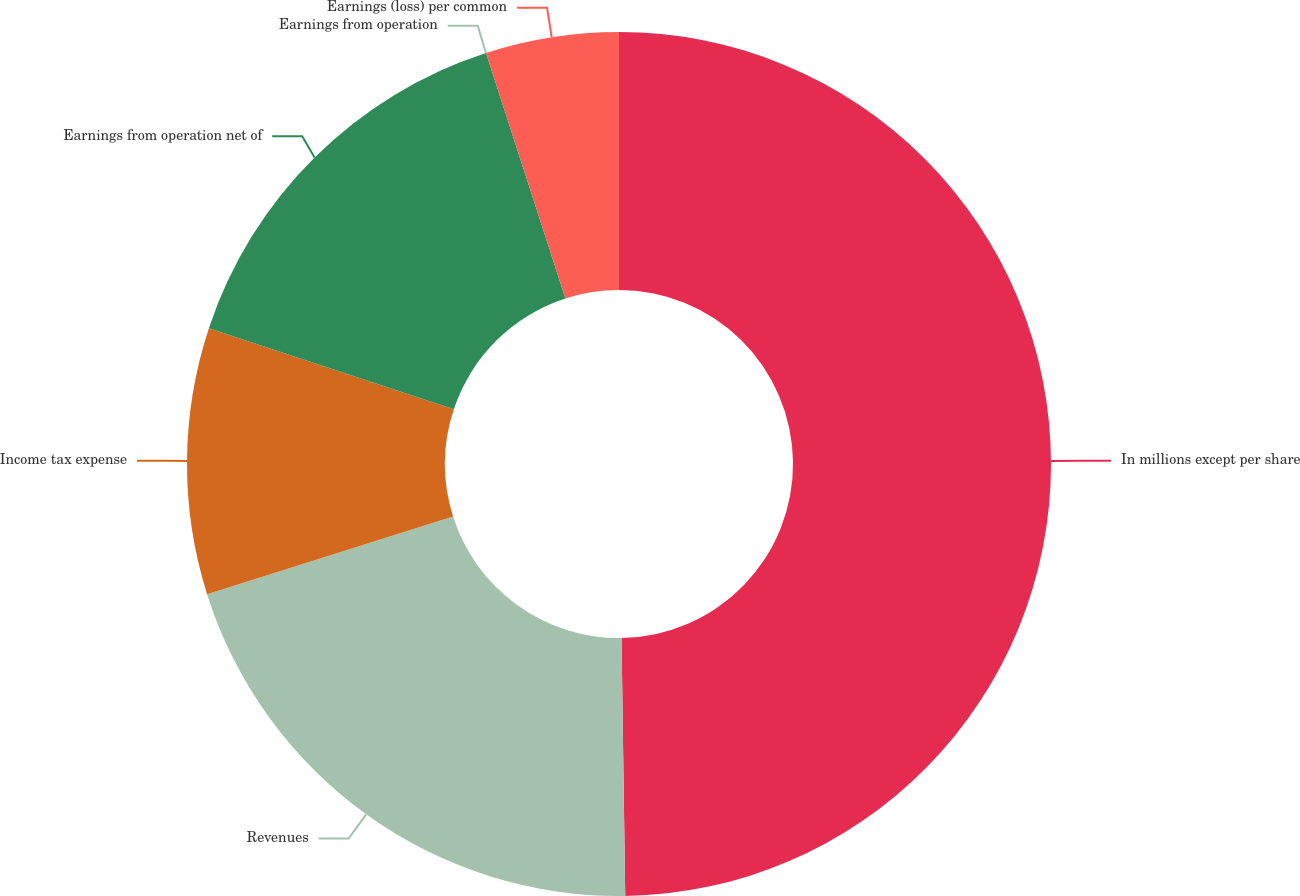Convert chart. <chart><loc_0><loc_0><loc_500><loc_500><pie_chart><fcel>In millions except per share<fcel>Revenues<fcel>Income tax expense<fcel>Earnings from operation net of<fcel>Earnings from operation<fcel>Earnings (loss) per common<nl><fcel>49.77%<fcel>20.36%<fcel>9.96%<fcel>14.93%<fcel>0.0%<fcel>4.98%<nl></chart> 